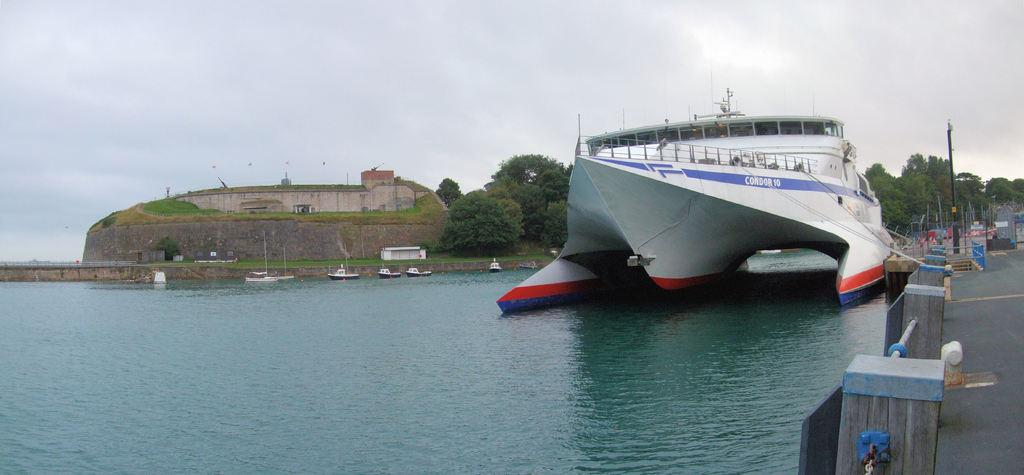What type of vehicles can be seen in the water in the image? There are boats and a ship in the water in the image. What else can be seen in the image besides the water vehicles? There is a road, trees, poles, boards, a house, and the sky visible in the image. Can you describe the house in the image? The house is a structure with walls and a roof, and it is located in the image. What is the background of the image? The sky is visible in the background of the image. What type of oil can be seen dripping from the feather in the image? There is no feather or oil present in the image. How does the image change when you look at it from a different angle? The image does not change when viewed from different angles, as it is a static image. 